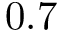<formula> <loc_0><loc_0><loc_500><loc_500>0 . 7</formula> 